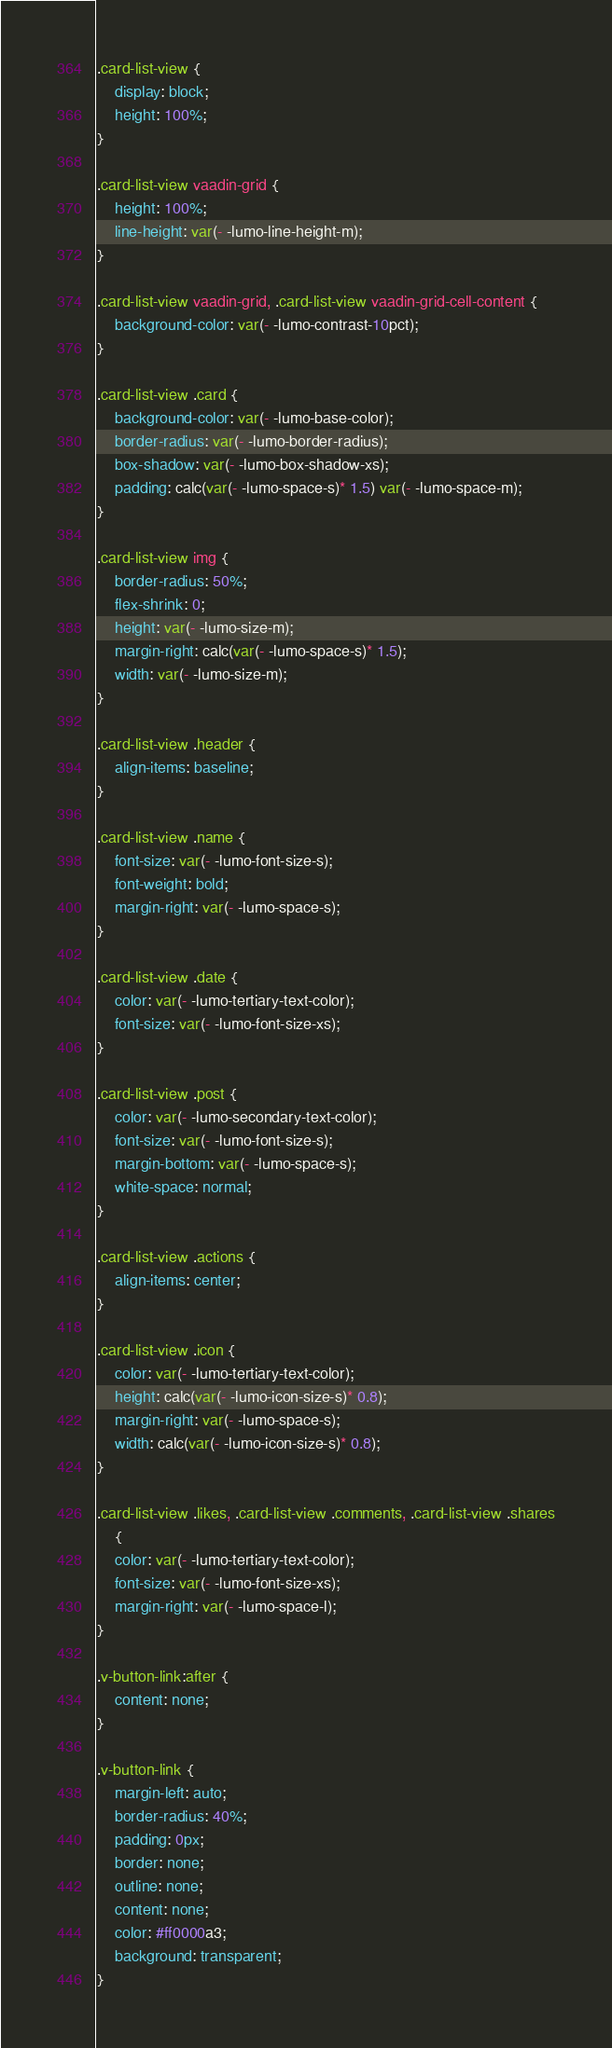<code> <loc_0><loc_0><loc_500><loc_500><_CSS_>.card-list-view {
	display: block;
	height: 100%;
}

.card-list-view vaadin-grid {
	height: 100%;
	line-height: var(- -lumo-line-height-m);
}

.card-list-view vaadin-grid, .card-list-view vaadin-grid-cell-content {
	background-color: var(- -lumo-contrast-10pct);
}

.card-list-view .card {
	background-color: var(- -lumo-base-color);
	border-radius: var(- -lumo-border-radius);
	box-shadow: var(- -lumo-box-shadow-xs);
	padding: calc(var(- -lumo-space-s)* 1.5) var(- -lumo-space-m);
}

.card-list-view img {
	border-radius: 50%;
	flex-shrink: 0;
	height: var(- -lumo-size-m);
	margin-right: calc(var(- -lumo-space-s)* 1.5);
	width: var(- -lumo-size-m);
}

.card-list-view .header {
	align-items: baseline;
}

.card-list-view .name {
	font-size: var(- -lumo-font-size-s);
	font-weight: bold;
	margin-right: var(- -lumo-space-s);
}

.card-list-view .date {
	color: var(- -lumo-tertiary-text-color);
	font-size: var(- -lumo-font-size-xs);
}

.card-list-view .post {
	color: var(- -lumo-secondary-text-color);
	font-size: var(- -lumo-font-size-s);
	margin-bottom: var(- -lumo-space-s);
	white-space: normal;
}

.card-list-view .actions {
	align-items: center;
}

.card-list-view .icon {
	color: var(- -lumo-tertiary-text-color);
	height: calc(var(- -lumo-icon-size-s)* 0.8);
	margin-right: var(- -lumo-space-s);
	width: calc(var(- -lumo-icon-size-s)* 0.8);
}

.card-list-view .likes, .card-list-view .comments, .card-list-view .shares
	{
	color: var(- -lumo-tertiary-text-color);
	font-size: var(- -lumo-font-size-xs);
	margin-right: var(- -lumo-space-l);
}

.v-button-link:after {
	content: none;
}

.v-button-link {
	margin-left: auto;
	border-radius: 40%;
	padding: 0px;
	border: none;
	outline: none;
	content: none;
	color: #ff0000a3;
	background: transparent;
}</code> 